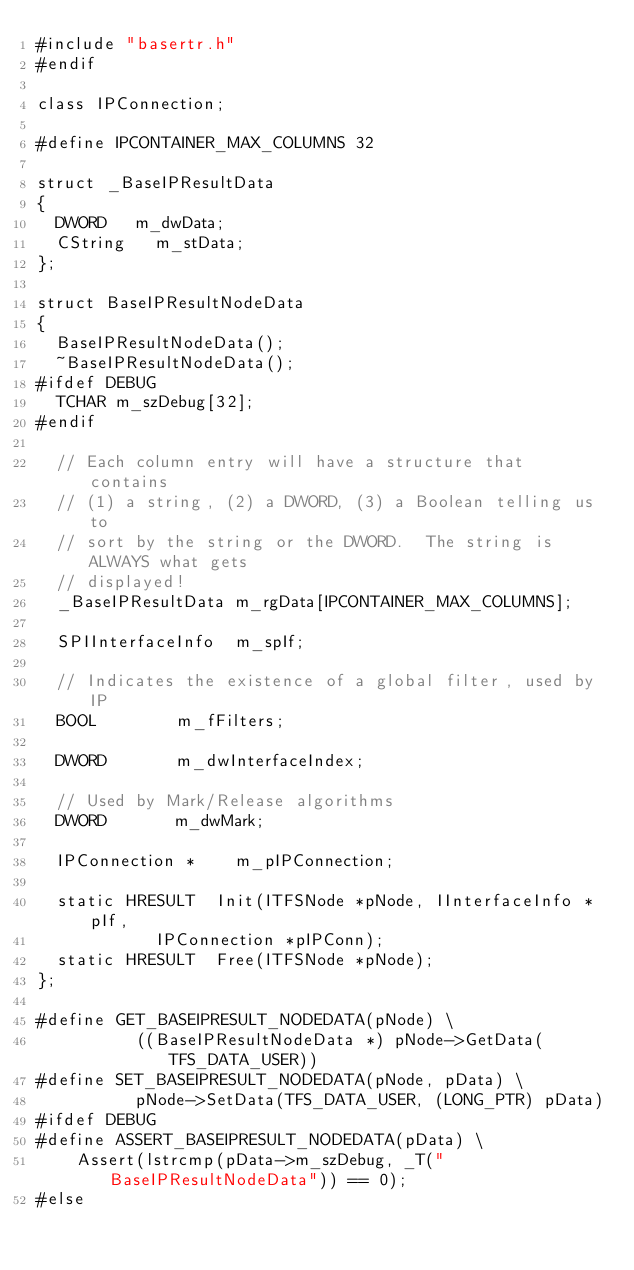<code> <loc_0><loc_0><loc_500><loc_500><_C_>#include "basertr.h"
#endif

class IPConnection;

#define IPCONTAINER_MAX_COLUMNS	32

struct _BaseIPResultData
{
	DWORD		m_dwData;
	CString		m_stData;
};

struct BaseIPResultNodeData
{
	BaseIPResultNodeData();
	~BaseIPResultNodeData();
#ifdef DEBUG
	TCHAR	m_szDebug[32];
#endif

	// Each column entry will have a structure that contains
	// (1) a string, (2) a DWORD, (3) a Boolean telling us to
	// sort by the string or the DWORD.  The string is ALWAYS what gets
	// displayed!
	_BaseIPResultData	m_rgData[IPCONTAINER_MAX_COLUMNS];

	SPIInterfaceInfo	m_spIf;

	// Indicates the existence of a global filter, used by IP
	BOOL				m_fFilters;

	DWORD				m_dwInterfaceIndex;

	// Used by Mark/Release algorithms
	DWORD				m_dwMark;

	IPConnection *		m_pIPConnection;

	static HRESULT	Init(ITFSNode *pNode, IInterfaceInfo *pIf,
						IPConnection *pIPConn);
	static HRESULT	Free(ITFSNode *pNode);
};

#define GET_BASEIPRESULT_NODEDATA(pNode) \
					((BaseIPResultNodeData *) pNode->GetData(TFS_DATA_USER))
#define SET_BASEIPRESULT_NODEDATA(pNode, pData) \
					pNode->SetData(TFS_DATA_USER, (LONG_PTR) pData)
#ifdef DEBUG
#define ASSERT_BASEIPRESULT_NODEDATA(pData) \
		Assert(lstrcmp(pData->m_szDebug, _T("BaseIPResultNodeData")) == 0);
#else</code> 